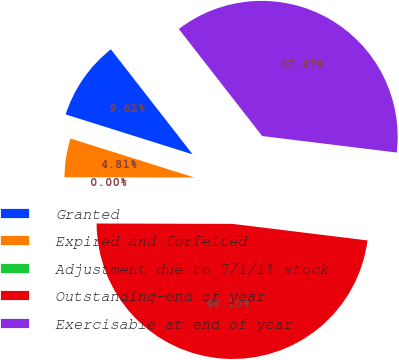Convert chart. <chart><loc_0><loc_0><loc_500><loc_500><pie_chart><fcel>Granted<fcel>Expired and forfeited<fcel>Adjustment due to 7/1/11 stock<fcel>Outstanding-end of year<fcel>Exercisable at end of year<nl><fcel>9.62%<fcel>4.81%<fcel>0.0%<fcel>48.1%<fcel>37.47%<nl></chart> 